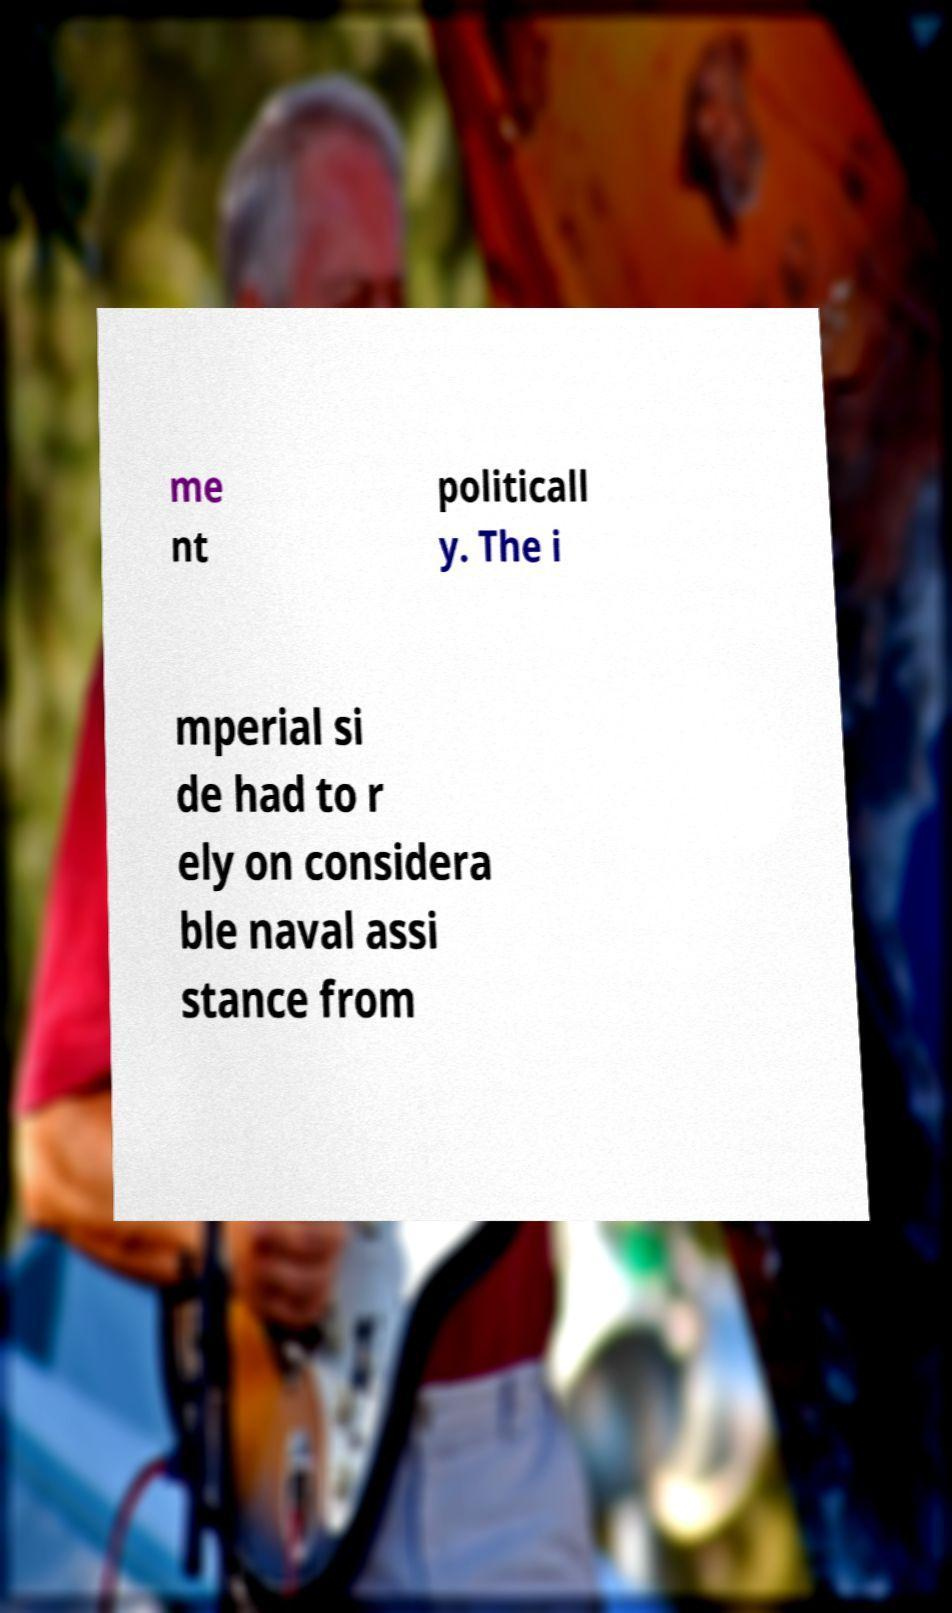Could you assist in decoding the text presented in this image and type it out clearly? me nt politicall y. The i mperial si de had to r ely on considera ble naval assi stance from 